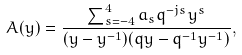Convert formula to latex. <formula><loc_0><loc_0><loc_500><loc_500>A ( y ) = \frac { \sum _ { s = - 4 } ^ { 4 } a _ { s } q ^ { - j s } y ^ { s } } { ( y - y ^ { - 1 } ) ( q y - q ^ { - 1 } y ^ { - 1 } ) } ,</formula> 